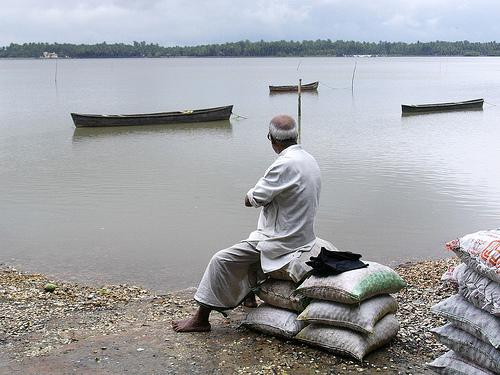What are found behind the water? Trees are found behind the water. Identify the color of the sky in the image. The sky is blue in color. What unusual objects are noticeable in the water? There are docking poles in the middle of the water. What is the man doing, and where is he sitting? The man is sitting on some packages, and he is barefooted. How many stacked bags are in the picture, and what color are they? There are three stacked bags, and they are white in color. How many canoes are in the water? There are three canoes in the water. What type of vegetation can be seen on the opposite shore? Green foliage can be seen on the opposite shore. Describe the condition and color of the water. The water is brown in color. What is the color of the man's hair? The man has grey hair. State the color and type of umbrella in the image. There is no umbrella visible in the image. 